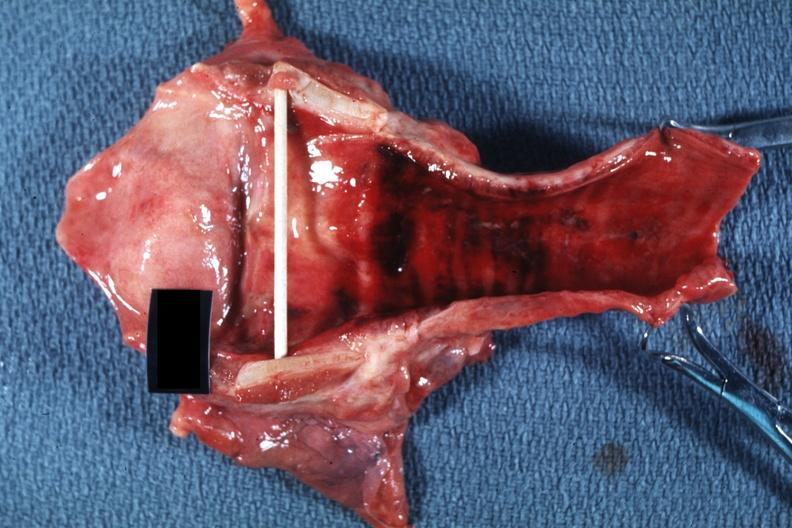s acute inflammation present?
Answer the question using a single word or phrase. Yes 